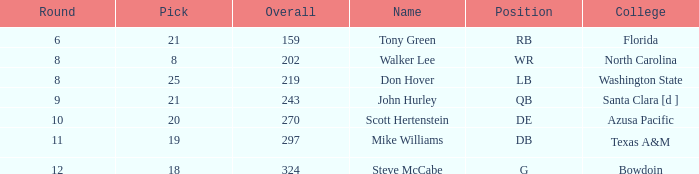What is the average overall for selections with a pick under 20, originating from north carolina college, and within the first 7 rounds? None. 